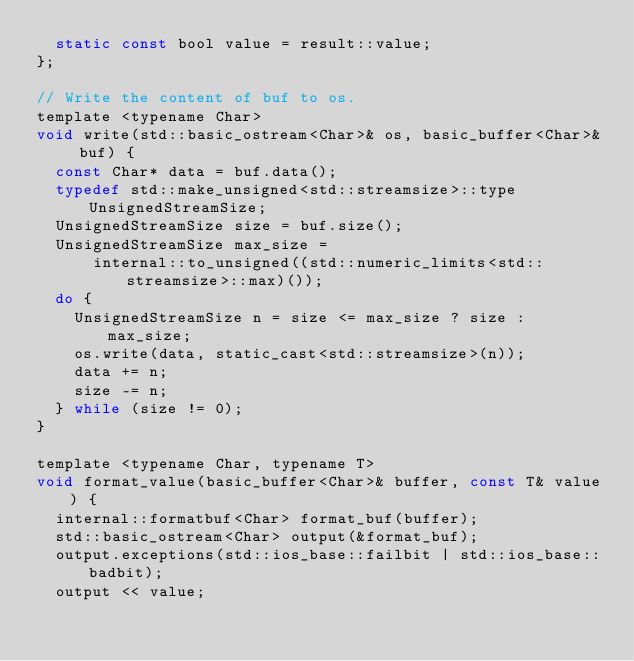Convert code to text. <code><loc_0><loc_0><loc_500><loc_500><_C_>  static const bool value = result::value;
};

// Write the content of buf to os.
template <typename Char>
void write(std::basic_ostream<Char>& os, basic_buffer<Char>& buf) {
  const Char* data = buf.data();
  typedef std::make_unsigned<std::streamsize>::type UnsignedStreamSize;
  UnsignedStreamSize size = buf.size();
  UnsignedStreamSize max_size =
      internal::to_unsigned((std::numeric_limits<std::streamsize>::max)());
  do {
    UnsignedStreamSize n = size <= max_size ? size : max_size;
    os.write(data, static_cast<std::streamsize>(n));
    data += n;
    size -= n;
  } while (size != 0);
}

template <typename Char, typename T>
void format_value(basic_buffer<Char>& buffer, const T& value) {
  internal::formatbuf<Char> format_buf(buffer);
  std::basic_ostream<Char> output(&format_buf);
  output.exceptions(std::ios_base::failbit | std::ios_base::badbit);
  output << value;</code> 